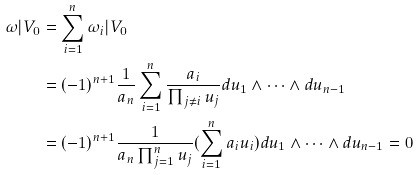Convert formula to latex. <formula><loc_0><loc_0><loc_500><loc_500>\omega | V _ { 0 } & = \sum _ { i = 1 } ^ { n } \omega _ { i } | V _ { 0 } \\ & = ( - 1 ) ^ { n + 1 } \frac { 1 } { a _ { n } } \sum _ { i = 1 } ^ { n } \frac { a _ { i } } { \prod _ { j \not = i } u _ { j } } d u _ { 1 } \wedge \cdots \wedge d u _ { n - 1 } \\ & = ( - 1 ) ^ { n + 1 } \frac { 1 } { a _ { n } \prod _ { j = 1 } ^ { n } u _ { j } } ( \sum _ { i = 1 } ^ { n } a _ { i } u _ { i } ) d u _ { 1 } \wedge \cdots \wedge d u _ { n - 1 } = 0</formula> 